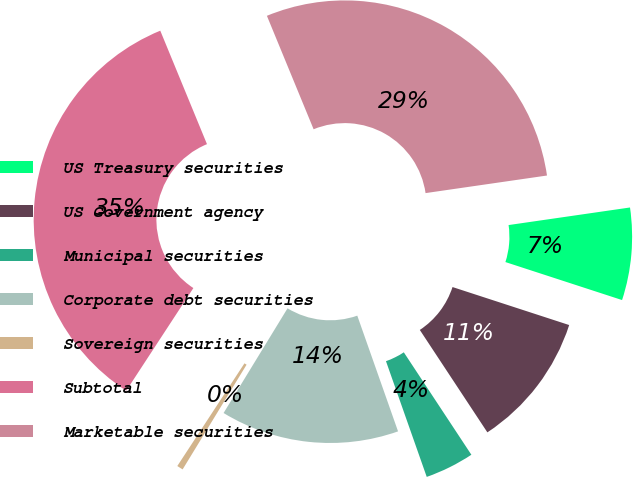<chart> <loc_0><loc_0><loc_500><loc_500><pie_chart><fcel>US Treasury securities<fcel>US Government agency<fcel>Municipal securities<fcel>Corporate debt securities<fcel>Sovereign securities<fcel>Subtotal<fcel>Marketable securities<nl><fcel>7.3%<fcel>10.71%<fcel>3.89%<fcel>14.12%<fcel>0.49%<fcel>34.57%<fcel>28.93%<nl></chart> 